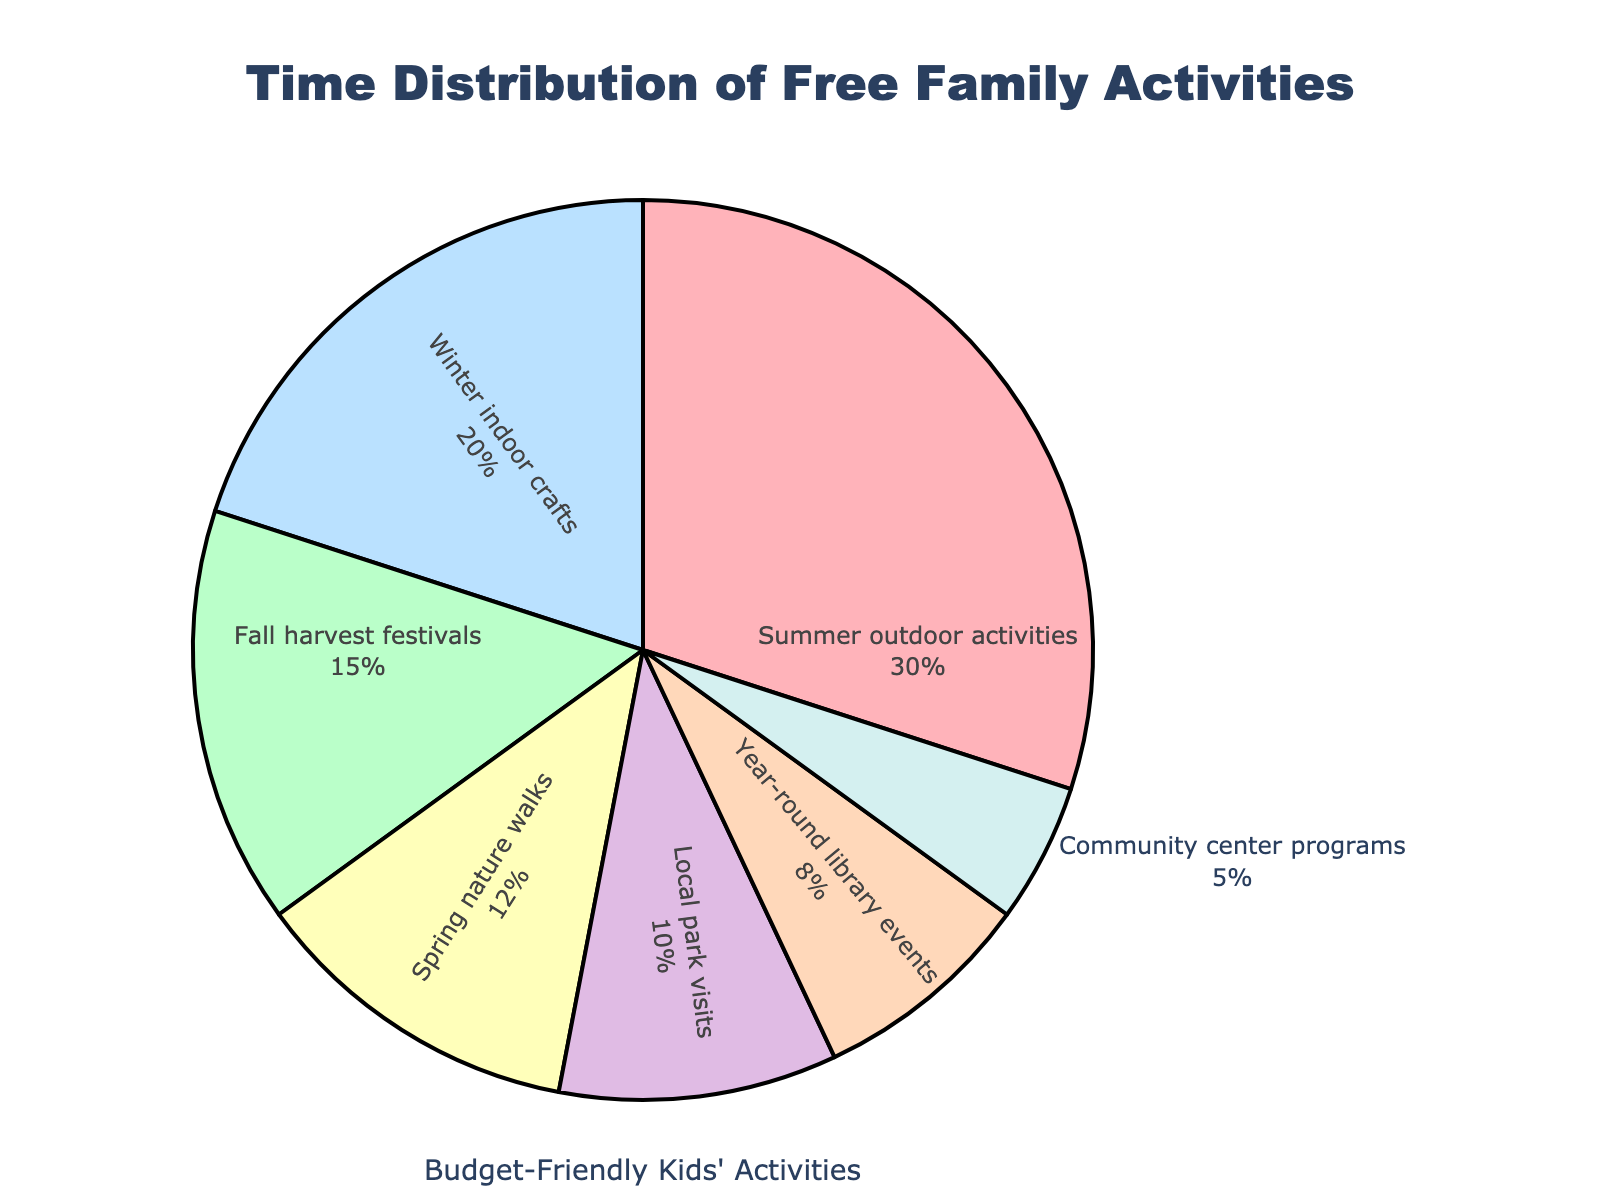what percentage of activities occur in Fall and Winter combined? To find the total percentage of Fall and Winter activities, add the percentages of Fall harvest festivals (15%) and Winter indoor crafts (20%). 15% + 20% = 35%
Answer: 35% Which category has the lowest percentage of time dedicated? By observing the pie chart and comparing all the sections, the category with the lowest percentage is Community center programs at 5%.
Answer: Community center programs How much more time is spent on summer outdoor activities compared to local park visits? Compare the percentage of Summer outdoor activities (30%) with Local park visits (10%). The difference is 30% - 10% = 20%.
Answer: 20% Which season has the most time spent on activities? By looking at the pie chart, the section with the largest percentage is Summer outdoor activities with 30%.
Answer: Summer What is the total percentage of activities that are available year-round? Adding the percentages of Year-round library events (8%) and Local park visits (10%), we get 8% + 10% = 18%.
Answer: 18% Are Spring nature walks more popular than year-round library events? By comparing the percentages, Spring nature walks have 12% while Year-round library events have 8%. Therefore, Spring nature walks are more popular.
Answer: Yes Which activity has the largest portion and what color represents it? The largest portion in the pie chart is Summer outdoor activities at 30%, and it is represented by the light red color.
Answer: Summer outdoor activities, light red How does the combined time for Spring and Winter activities compare to Summer activities? Sum the percentages of Spring nature walks (12%) and Winter indoor crafts (20%) to get 12% + 20% = 32%. Summer outdoor activities are 30%. Since 32% > 30%, the combined time for Spring and Winter is greater.
Answer: 32% > 30% 